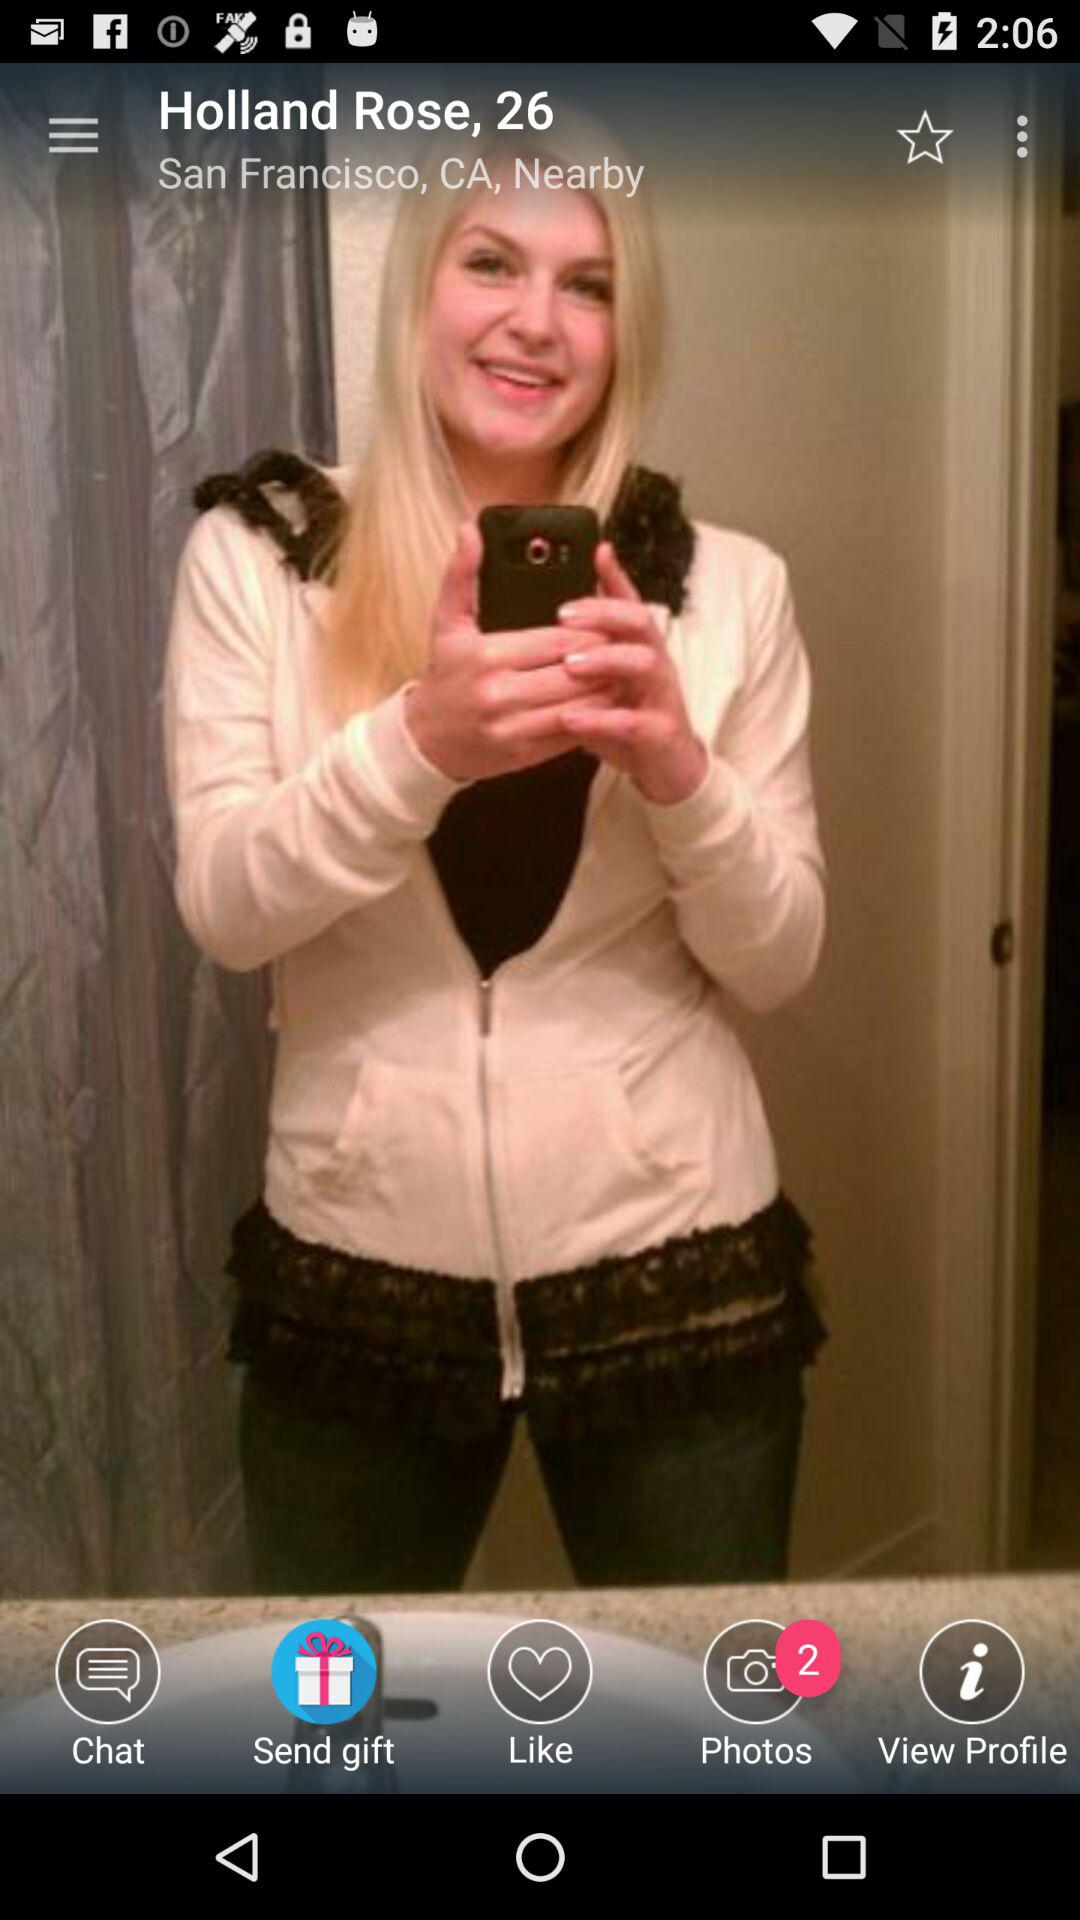What is her age? Her age is 26 years. 